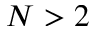Convert formula to latex. <formula><loc_0><loc_0><loc_500><loc_500>N > 2</formula> 